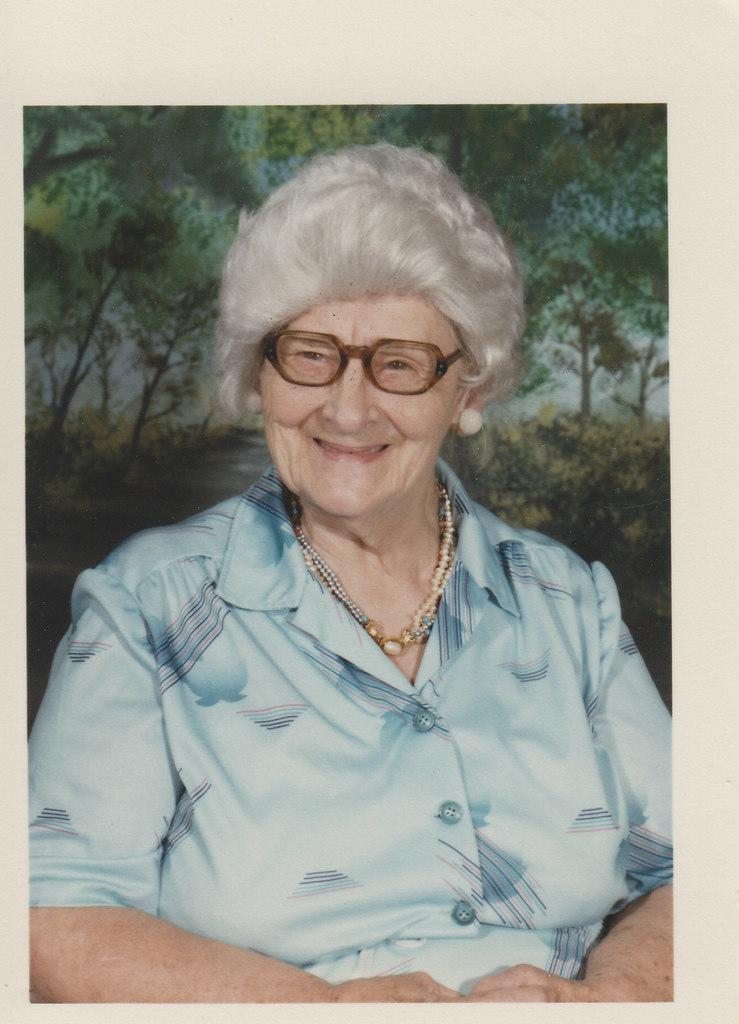What type of artwork is depicted in the image? The image is a painting. Who is the main subject in the painting? There is a woman in the painting. What is the woman doing in the painting? The woman is smiling in the painting. What accessories is the woman wearing in the painting? The woman is wearing a spectacle, a necklace, and earrings in the painting. What type of clothing is the woman wearing in the painting? The woman is wearing a dress in the painting. What can be seen in the background of the painting? There are trees in the background of the painting. How many feet are visible in the painting? There are no feet visible in the painting, as it is a painting of a woman. 